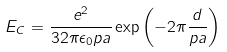Convert formula to latex. <formula><loc_0><loc_0><loc_500><loc_500>E _ { C } = \frac { e ^ { 2 } } { 3 2 \pi \epsilon _ { 0 } p a } \exp \left ( - 2 \pi \frac { d } { p a } \right )</formula> 